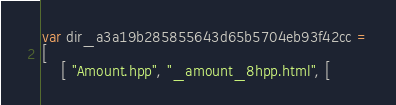Convert code to text. <code><loc_0><loc_0><loc_500><loc_500><_JavaScript_>var dir_a3a19b285855643d65b5704eb93f42cc =
[
    [ "Amount.hpp", "_amount_8hpp.html", [</code> 